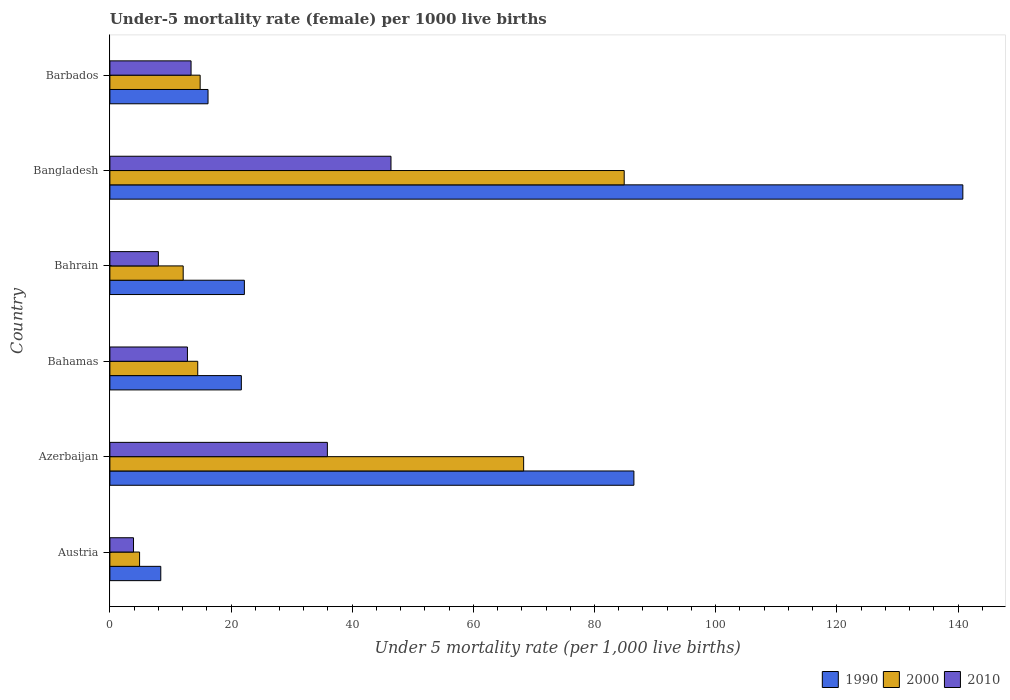How many different coloured bars are there?
Your answer should be very brief. 3. Are the number of bars per tick equal to the number of legend labels?
Keep it short and to the point. Yes. How many bars are there on the 1st tick from the top?
Ensure brevity in your answer.  3. In how many cases, is the number of bars for a given country not equal to the number of legend labels?
Give a very brief answer. 0. What is the under-five mortality rate in 1990 in Austria?
Make the answer very short. 8.4. Across all countries, what is the maximum under-five mortality rate in 2000?
Ensure brevity in your answer.  84.9. Across all countries, what is the minimum under-five mortality rate in 2010?
Your answer should be compact. 3.9. In which country was the under-five mortality rate in 1990 minimum?
Your response must be concise. Austria. What is the total under-five mortality rate in 1990 in the graph?
Give a very brief answer. 295.8. What is the difference between the under-five mortality rate in 2010 in Bangladesh and the under-five mortality rate in 1990 in Bahrain?
Your answer should be compact. 24.2. What is the average under-five mortality rate in 2010 per country?
Offer a very short reply. 20.07. What is the difference between the under-five mortality rate in 1990 and under-five mortality rate in 2000 in Barbados?
Keep it short and to the point. 1.3. In how many countries, is the under-five mortality rate in 1990 greater than 56 ?
Your response must be concise. 2. What is the ratio of the under-five mortality rate in 2010 in Azerbaijan to that in Bahamas?
Give a very brief answer. 2.8. What is the difference between the highest and the lowest under-five mortality rate in 2000?
Make the answer very short. 80. What does the 2nd bar from the top in Azerbaijan represents?
Your answer should be very brief. 2000. Is it the case that in every country, the sum of the under-five mortality rate in 1990 and under-five mortality rate in 2000 is greater than the under-five mortality rate in 2010?
Offer a terse response. Yes. How many bars are there?
Your answer should be compact. 18. How many countries are there in the graph?
Offer a very short reply. 6. What is the difference between two consecutive major ticks on the X-axis?
Provide a succinct answer. 20. Does the graph contain any zero values?
Your response must be concise. No. What is the title of the graph?
Ensure brevity in your answer.  Under-5 mortality rate (female) per 1000 live births. Does "2007" appear as one of the legend labels in the graph?
Give a very brief answer. No. What is the label or title of the X-axis?
Keep it short and to the point. Under 5 mortality rate (per 1,0 live births). What is the label or title of the Y-axis?
Your answer should be very brief. Country. What is the Under 5 mortality rate (per 1,000 live births) in 1990 in Austria?
Your answer should be compact. 8.4. What is the Under 5 mortality rate (per 1,000 live births) of 2000 in Austria?
Provide a short and direct response. 4.9. What is the Under 5 mortality rate (per 1,000 live births) in 1990 in Azerbaijan?
Ensure brevity in your answer.  86.5. What is the Under 5 mortality rate (per 1,000 live births) of 2000 in Azerbaijan?
Your answer should be very brief. 68.3. What is the Under 5 mortality rate (per 1,000 live births) in 2010 in Azerbaijan?
Keep it short and to the point. 35.9. What is the Under 5 mortality rate (per 1,000 live births) of 1990 in Bahamas?
Provide a short and direct response. 21.7. What is the Under 5 mortality rate (per 1,000 live births) of 2010 in Bahamas?
Your answer should be compact. 12.8. What is the Under 5 mortality rate (per 1,000 live births) in 1990 in Bahrain?
Offer a very short reply. 22.2. What is the Under 5 mortality rate (per 1,000 live births) of 2010 in Bahrain?
Your answer should be very brief. 8. What is the Under 5 mortality rate (per 1,000 live births) in 1990 in Bangladesh?
Your answer should be very brief. 140.8. What is the Under 5 mortality rate (per 1,000 live births) of 2000 in Bangladesh?
Make the answer very short. 84.9. What is the Under 5 mortality rate (per 1,000 live births) in 2010 in Bangladesh?
Provide a short and direct response. 46.4. What is the Under 5 mortality rate (per 1,000 live births) of 2010 in Barbados?
Your answer should be very brief. 13.4. Across all countries, what is the maximum Under 5 mortality rate (per 1,000 live births) in 1990?
Provide a succinct answer. 140.8. Across all countries, what is the maximum Under 5 mortality rate (per 1,000 live births) in 2000?
Offer a terse response. 84.9. Across all countries, what is the maximum Under 5 mortality rate (per 1,000 live births) in 2010?
Provide a succinct answer. 46.4. Across all countries, what is the minimum Under 5 mortality rate (per 1,000 live births) of 2000?
Your answer should be very brief. 4.9. What is the total Under 5 mortality rate (per 1,000 live births) of 1990 in the graph?
Provide a short and direct response. 295.8. What is the total Under 5 mortality rate (per 1,000 live births) in 2000 in the graph?
Ensure brevity in your answer.  199.6. What is the total Under 5 mortality rate (per 1,000 live births) of 2010 in the graph?
Give a very brief answer. 120.4. What is the difference between the Under 5 mortality rate (per 1,000 live births) of 1990 in Austria and that in Azerbaijan?
Your answer should be very brief. -78.1. What is the difference between the Under 5 mortality rate (per 1,000 live births) in 2000 in Austria and that in Azerbaijan?
Provide a succinct answer. -63.4. What is the difference between the Under 5 mortality rate (per 1,000 live births) of 2010 in Austria and that in Azerbaijan?
Give a very brief answer. -32. What is the difference between the Under 5 mortality rate (per 1,000 live births) in 1990 in Austria and that in Bahamas?
Your answer should be compact. -13.3. What is the difference between the Under 5 mortality rate (per 1,000 live births) in 2000 in Austria and that in Bahamas?
Make the answer very short. -9.6. What is the difference between the Under 5 mortality rate (per 1,000 live births) of 1990 in Austria and that in Bahrain?
Provide a short and direct response. -13.8. What is the difference between the Under 5 mortality rate (per 1,000 live births) in 2010 in Austria and that in Bahrain?
Provide a succinct answer. -4.1. What is the difference between the Under 5 mortality rate (per 1,000 live births) in 1990 in Austria and that in Bangladesh?
Ensure brevity in your answer.  -132.4. What is the difference between the Under 5 mortality rate (per 1,000 live births) of 2000 in Austria and that in Bangladesh?
Offer a terse response. -80. What is the difference between the Under 5 mortality rate (per 1,000 live births) in 2010 in Austria and that in Bangladesh?
Ensure brevity in your answer.  -42.5. What is the difference between the Under 5 mortality rate (per 1,000 live births) of 2000 in Austria and that in Barbados?
Keep it short and to the point. -10. What is the difference between the Under 5 mortality rate (per 1,000 live births) in 1990 in Azerbaijan and that in Bahamas?
Ensure brevity in your answer.  64.8. What is the difference between the Under 5 mortality rate (per 1,000 live births) of 2000 in Azerbaijan and that in Bahamas?
Your answer should be compact. 53.8. What is the difference between the Under 5 mortality rate (per 1,000 live births) of 2010 in Azerbaijan and that in Bahamas?
Provide a succinct answer. 23.1. What is the difference between the Under 5 mortality rate (per 1,000 live births) of 1990 in Azerbaijan and that in Bahrain?
Offer a terse response. 64.3. What is the difference between the Under 5 mortality rate (per 1,000 live births) of 2000 in Azerbaijan and that in Bahrain?
Give a very brief answer. 56.2. What is the difference between the Under 5 mortality rate (per 1,000 live births) of 2010 in Azerbaijan and that in Bahrain?
Make the answer very short. 27.9. What is the difference between the Under 5 mortality rate (per 1,000 live births) of 1990 in Azerbaijan and that in Bangladesh?
Your response must be concise. -54.3. What is the difference between the Under 5 mortality rate (per 1,000 live births) of 2000 in Azerbaijan and that in Bangladesh?
Offer a terse response. -16.6. What is the difference between the Under 5 mortality rate (per 1,000 live births) of 2010 in Azerbaijan and that in Bangladesh?
Provide a short and direct response. -10.5. What is the difference between the Under 5 mortality rate (per 1,000 live births) of 1990 in Azerbaijan and that in Barbados?
Keep it short and to the point. 70.3. What is the difference between the Under 5 mortality rate (per 1,000 live births) in 2000 in Azerbaijan and that in Barbados?
Provide a succinct answer. 53.4. What is the difference between the Under 5 mortality rate (per 1,000 live births) in 2010 in Azerbaijan and that in Barbados?
Your answer should be very brief. 22.5. What is the difference between the Under 5 mortality rate (per 1,000 live births) in 2000 in Bahamas and that in Bahrain?
Provide a succinct answer. 2.4. What is the difference between the Under 5 mortality rate (per 1,000 live births) of 1990 in Bahamas and that in Bangladesh?
Ensure brevity in your answer.  -119.1. What is the difference between the Under 5 mortality rate (per 1,000 live births) of 2000 in Bahamas and that in Bangladesh?
Provide a succinct answer. -70.4. What is the difference between the Under 5 mortality rate (per 1,000 live births) in 2010 in Bahamas and that in Bangladesh?
Ensure brevity in your answer.  -33.6. What is the difference between the Under 5 mortality rate (per 1,000 live births) of 1990 in Bahamas and that in Barbados?
Your answer should be very brief. 5.5. What is the difference between the Under 5 mortality rate (per 1,000 live births) of 2010 in Bahamas and that in Barbados?
Keep it short and to the point. -0.6. What is the difference between the Under 5 mortality rate (per 1,000 live births) of 1990 in Bahrain and that in Bangladesh?
Provide a succinct answer. -118.6. What is the difference between the Under 5 mortality rate (per 1,000 live births) in 2000 in Bahrain and that in Bangladesh?
Your response must be concise. -72.8. What is the difference between the Under 5 mortality rate (per 1,000 live births) in 2010 in Bahrain and that in Bangladesh?
Offer a terse response. -38.4. What is the difference between the Under 5 mortality rate (per 1,000 live births) of 2000 in Bahrain and that in Barbados?
Keep it short and to the point. -2.8. What is the difference between the Under 5 mortality rate (per 1,000 live births) of 2010 in Bahrain and that in Barbados?
Offer a terse response. -5.4. What is the difference between the Under 5 mortality rate (per 1,000 live births) in 1990 in Bangladesh and that in Barbados?
Your answer should be compact. 124.6. What is the difference between the Under 5 mortality rate (per 1,000 live births) in 2000 in Bangladesh and that in Barbados?
Provide a short and direct response. 70. What is the difference between the Under 5 mortality rate (per 1,000 live births) in 2010 in Bangladesh and that in Barbados?
Your answer should be compact. 33. What is the difference between the Under 5 mortality rate (per 1,000 live births) in 1990 in Austria and the Under 5 mortality rate (per 1,000 live births) in 2000 in Azerbaijan?
Offer a very short reply. -59.9. What is the difference between the Under 5 mortality rate (per 1,000 live births) in 1990 in Austria and the Under 5 mortality rate (per 1,000 live births) in 2010 in Azerbaijan?
Ensure brevity in your answer.  -27.5. What is the difference between the Under 5 mortality rate (per 1,000 live births) in 2000 in Austria and the Under 5 mortality rate (per 1,000 live births) in 2010 in Azerbaijan?
Give a very brief answer. -31. What is the difference between the Under 5 mortality rate (per 1,000 live births) in 1990 in Austria and the Under 5 mortality rate (per 1,000 live births) in 2010 in Bahrain?
Provide a succinct answer. 0.4. What is the difference between the Under 5 mortality rate (per 1,000 live births) of 2000 in Austria and the Under 5 mortality rate (per 1,000 live births) of 2010 in Bahrain?
Provide a succinct answer. -3.1. What is the difference between the Under 5 mortality rate (per 1,000 live births) in 1990 in Austria and the Under 5 mortality rate (per 1,000 live births) in 2000 in Bangladesh?
Your response must be concise. -76.5. What is the difference between the Under 5 mortality rate (per 1,000 live births) in 1990 in Austria and the Under 5 mortality rate (per 1,000 live births) in 2010 in Bangladesh?
Provide a short and direct response. -38. What is the difference between the Under 5 mortality rate (per 1,000 live births) in 2000 in Austria and the Under 5 mortality rate (per 1,000 live births) in 2010 in Bangladesh?
Give a very brief answer. -41.5. What is the difference between the Under 5 mortality rate (per 1,000 live births) in 2000 in Austria and the Under 5 mortality rate (per 1,000 live births) in 2010 in Barbados?
Provide a short and direct response. -8.5. What is the difference between the Under 5 mortality rate (per 1,000 live births) of 1990 in Azerbaijan and the Under 5 mortality rate (per 1,000 live births) of 2000 in Bahamas?
Offer a very short reply. 72. What is the difference between the Under 5 mortality rate (per 1,000 live births) of 1990 in Azerbaijan and the Under 5 mortality rate (per 1,000 live births) of 2010 in Bahamas?
Your answer should be compact. 73.7. What is the difference between the Under 5 mortality rate (per 1,000 live births) of 2000 in Azerbaijan and the Under 5 mortality rate (per 1,000 live births) of 2010 in Bahamas?
Your answer should be very brief. 55.5. What is the difference between the Under 5 mortality rate (per 1,000 live births) of 1990 in Azerbaijan and the Under 5 mortality rate (per 1,000 live births) of 2000 in Bahrain?
Offer a very short reply. 74.4. What is the difference between the Under 5 mortality rate (per 1,000 live births) of 1990 in Azerbaijan and the Under 5 mortality rate (per 1,000 live births) of 2010 in Bahrain?
Offer a terse response. 78.5. What is the difference between the Under 5 mortality rate (per 1,000 live births) of 2000 in Azerbaijan and the Under 5 mortality rate (per 1,000 live births) of 2010 in Bahrain?
Keep it short and to the point. 60.3. What is the difference between the Under 5 mortality rate (per 1,000 live births) in 1990 in Azerbaijan and the Under 5 mortality rate (per 1,000 live births) in 2000 in Bangladesh?
Provide a short and direct response. 1.6. What is the difference between the Under 5 mortality rate (per 1,000 live births) of 1990 in Azerbaijan and the Under 5 mortality rate (per 1,000 live births) of 2010 in Bangladesh?
Offer a terse response. 40.1. What is the difference between the Under 5 mortality rate (per 1,000 live births) in 2000 in Azerbaijan and the Under 5 mortality rate (per 1,000 live births) in 2010 in Bangladesh?
Provide a succinct answer. 21.9. What is the difference between the Under 5 mortality rate (per 1,000 live births) in 1990 in Azerbaijan and the Under 5 mortality rate (per 1,000 live births) in 2000 in Barbados?
Give a very brief answer. 71.6. What is the difference between the Under 5 mortality rate (per 1,000 live births) in 1990 in Azerbaijan and the Under 5 mortality rate (per 1,000 live births) in 2010 in Barbados?
Offer a very short reply. 73.1. What is the difference between the Under 5 mortality rate (per 1,000 live births) in 2000 in Azerbaijan and the Under 5 mortality rate (per 1,000 live births) in 2010 in Barbados?
Keep it short and to the point. 54.9. What is the difference between the Under 5 mortality rate (per 1,000 live births) of 1990 in Bahamas and the Under 5 mortality rate (per 1,000 live births) of 2000 in Bahrain?
Provide a succinct answer. 9.6. What is the difference between the Under 5 mortality rate (per 1,000 live births) of 1990 in Bahamas and the Under 5 mortality rate (per 1,000 live births) of 2010 in Bahrain?
Your response must be concise. 13.7. What is the difference between the Under 5 mortality rate (per 1,000 live births) in 2000 in Bahamas and the Under 5 mortality rate (per 1,000 live births) in 2010 in Bahrain?
Keep it short and to the point. 6.5. What is the difference between the Under 5 mortality rate (per 1,000 live births) in 1990 in Bahamas and the Under 5 mortality rate (per 1,000 live births) in 2000 in Bangladesh?
Your answer should be very brief. -63.2. What is the difference between the Under 5 mortality rate (per 1,000 live births) in 1990 in Bahamas and the Under 5 mortality rate (per 1,000 live births) in 2010 in Bangladesh?
Your answer should be compact. -24.7. What is the difference between the Under 5 mortality rate (per 1,000 live births) in 2000 in Bahamas and the Under 5 mortality rate (per 1,000 live births) in 2010 in Bangladesh?
Offer a terse response. -31.9. What is the difference between the Under 5 mortality rate (per 1,000 live births) of 1990 in Bahamas and the Under 5 mortality rate (per 1,000 live births) of 2010 in Barbados?
Your response must be concise. 8.3. What is the difference between the Under 5 mortality rate (per 1,000 live births) in 1990 in Bahrain and the Under 5 mortality rate (per 1,000 live births) in 2000 in Bangladesh?
Offer a very short reply. -62.7. What is the difference between the Under 5 mortality rate (per 1,000 live births) in 1990 in Bahrain and the Under 5 mortality rate (per 1,000 live births) in 2010 in Bangladesh?
Offer a terse response. -24.2. What is the difference between the Under 5 mortality rate (per 1,000 live births) in 2000 in Bahrain and the Under 5 mortality rate (per 1,000 live births) in 2010 in Bangladesh?
Your answer should be very brief. -34.3. What is the difference between the Under 5 mortality rate (per 1,000 live births) in 1990 in Bahrain and the Under 5 mortality rate (per 1,000 live births) in 2000 in Barbados?
Ensure brevity in your answer.  7.3. What is the difference between the Under 5 mortality rate (per 1,000 live births) in 1990 in Bahrain and the Under 5 mortality rate (per 1,000 live births) in 2010 in Barbados?
Give a very brief answer. 8.8. What is the difference between the Under 5 mortality rate (per 1,000 live births) in 2000 in Bahrain and the Under 5 mortality rate (per 1,000 live births) in 2010 in Barbados?
Your answer should be compact. -1.3. What is the difference between the Under 5 mortality rate (per 1,000 live births) in 1990 in Bangladesh and the Under 5 mortality rate (per 1,000 live births) in 2000 in Barbados?
Provide a succinct answer. 125.9. What is the difference between the Under 5 mortality rate (per 1,000 live births) in 1990 in Bangladesh and the Under 5 mortality rate (per 1,000 live births) in 2010 in Barbados?
Keep it short and to the point. 127.4. What is the difference between the Under 5 mortality rate (per 1,000 live births) in 2000 in Bangladesh and the Under 5 mortality rate (per 1,000 live births) in 2010 in Barbados?
Ensure brevity in your answer.  71.5. What is the average Under 5 mortality rate (per 1,000 live births) in 1990 per country?
Your answer should be very brief. 49.3. What is the average Under 5 mortality rate (per 1,000 live births) of 2000 per country?
Provide a short and direct response. 33.27. What is the average Under 5 mortality rate (per 1,000 live births) in 2010 per country?
Keep it short and to the point. 20.07. What is the difference between the Under 5 mortality rate (per 1,000 live births) of 1990 and Under 5 mortality rate (per 1,000 live births) of 2010 in Azerbaijan?
Your answer should be very brief. 50.6. What is the difference between the Under 5 mortality rate (per 1,000 live births) of 2000 and Under 5 mortality rate (per 1,000 live births) of 2010 in Azerbaijan?
Your answer should be very brief. 32.4. What is the difference between the Under 5 mortality rate (per 1,000 live births) in 1990 and Under 5 mortality rate (per 1,000 live births) in 2010 in Bahamas?
Offer a terse response. 8.9. What is the difference between the Under 5 mortality rate (per 1,000 live births) in 2000 and Under 5 mortality rate (per 1,000 live births) in 2010 in Bahamas?
Provide a short and direct response. 1.7. What is the difference between the Under 5 mortality rate (per 1,000 live births) in 1990 and Under 5 mortality rate (per 1,000 live births) in 2000 in Bahrain?
Offer a terse response. 10.1. What is the difference between the Under 5 mortality rate (per 1,000 live births) in 1990 and Under 5 mortality rate (per 1,000 live births) in 2010 in Bahrain?
Provide a succinct answer. 14.2. What is the difference between the Under 5 mortality rate (per 1,000 live births) of 2000 and Under 5 mortality rate (per 1,000 live births) of 2010 in Bahrain?
Keep it short and to the point. 4.1. What is the difference between the Under 5 mortality rate (per 1,000 live births) in 1990 and Under 5 mortality rate (per 1,000 live births) in 2000 in Bangladesh?
Provide a short and direct response. 55.9. What is the difference between the Under 5 mortality rate (per 1,000 live births) of 1990 and Under 5 mortality rate (per 1,000 live births) of 2010 in Bangladesh?
Your answer should be very brief. 94.4. What is the difference between the Under 5 mortality rate (per 1,000 live births) of 2000 and Under 5 mortality rate (per 1,000 live births) of 2010 in Bangladesh?
Your answer should be very brief. 38.5. What is the difference between the Under 5 mortality rate (per 1,000 live births) of 2000 and Under 5 mortality rate (per 1,000 live births) of 2010 in Barbados?
Ensure brevity in your answer.  1.5. What is the ratio of the Under 5 mortality rate (per 1,000 live births) of 1990 in Austria to that in Azerbaijan?
Offer a terse response. 0.1. What is the ratio of the Under 5 mortality rate (per 1,000 live births) of 2000 in Austria to that in Azerbaijan?
Offer a very short reply. 0.07. What is the ratio of the Under 5 mortality rate (per 1,000 live births) of 2010 in Austria to that in Azerbaijan?
Ensure brevity in your answer.  0.11. What is the ratio of the Under 5 mortality rate (per 1,000 live births) in 1990 in Austria to that in Bahamas?
Give a very brief answer. 0.39. What is the ratio of the Under 5 mortality rate (per 1,000 live births) of 2000 in Austria to that in Bahamas?
Offer a very short reply. 0.34. What is the ratio of the Under 5 mortality rate (per 1,000 live births) in 2010 in Austria to that in Bahamas?
Provide a short and direct response. 0.3. What is the ratio of the Under 5 mortality rate (per 1,000 live births) in 1990 in Austria to that in Bahrain?
Make the answer very short. 0.38. What is the ratio of the Under 5 mortality rate (per 1,000 live births) in 2000 in Austria to that in Bahrain?
Offer a very short reply. 0.41. What is the ratio of the Under 5 mortality rate (per 1,000 live births) in 2010 in Austria to that in Bahrain?
Offer a terse response. 0.49. What is the ratio of the Under 5 mortality rate (per 1,000 live births) of 1990 in Austria to that in Bangladesh?
Make the answer very short. 0.06. What is the ratio of the Under 5 mortality rate (per 1,000 live births) in 2000 in Austria to that in Bangladesh?
Offer a very short reply. 0.06. What is the ratio of the Under 5 mortality rate (per 1,000 live births) of 2010 in Austria to that in Bangladesh?
Provide a succinct answer. 0.08. What is the ratio of the Under 5 mortality rate (per 1,000 live births) of 1990 in Austria to that in Barbados?
Provide a short and direct response. 0.52. What is the ratio of the Under 5 mortality rate (per 1,000 live births) in 2000 in Austria to that in Barbados?
Offer a terse response. 0.33. What is the ratio of the Under 5 mortality rate (per 1,000 live births) in 2010 in Austria to that in Barbados?
Offer a terse response. 0.29. What is the ratio of the Under 5 mortality rate (per 1,000 live births) in 1990 in Azerbaijan to that in Bahamas?
Provide a short and direct response. 3.99. What is the ratio of the Under 5 mortality rate (per 1,000 live births) in 2000 in Azerbaijan to that in Bahamas?
Keep it short and to the point. 4.71. What is the ratio of the Under 5 mortality rate (per 1,000 live births) in 2010 in Azerbaijan to that in Bahamas?
Your answer should be compact. 2.8. What is the ratio of the Under 5 mortality rate (per 1,000 live births) in 1990 in Azerbaijan to that in Bahrain?
Your answer should be compact. 3.9. What is the ratio of the Under 5 mortality rate (per 1,000 live births) in 2000 in Azerbaijan to that in Bahrain?
Your answer should be very brief. 5.64. What is the ratio of the Under 5 mortality rate (per 1,000 live births) in 2010 in Azerbaijan to that in Bahrain?
Ensure brevity in your answer.  4.49. What is the ratio of the Under 5 mortality rate (per 1,000 live births) of 1990 in Azerbaijan to that in Bangladesh?
Offer a very short reply. 0.61. What is the ratio of the Under 5 mortality rate (per 1,000 live births) of 2000 in Azerbaijan to that in Bangladesh?
Offer a terse response. 0.8. What is the ratio of the Under 5 mortality rate (per 1,000 live births) of 2010 in Azerbaijan to that in Bangladesh?
Your response must be concise. 0.77. What is the ratio of the Under 5 mortality rate (per 1,000 live births) of 1990 in Azerbaijan to that in Barbados?
Offer a terse response. 5.34. What is the ratio of the Under 5 mortality rate (per 1,000 live births) of 2000 in Azerbaijan to that in Barbados?
Your response must be concise. 4.58. What is the ratio of the Under 5 mortality rate (per 1,000 live births) in 2010 in Azerbaijan to that in Barbados?
Your answer should be very brief. 2.68. What is the ratio of the Under 5 mortality rate (per 1,000 live births) in 1990 in Bahamas to that in Bahrain?
Give a very brief answer. 0.98. What is the ratio of the Under 5 mortality rate (per 1,000 live births) in 2000 in Bahamas to that in Bahrain?
Make the answer very short. 1.2. What is the ratio of the Under 5 mortality rate (per 1,000 live births) of 1990 in Bahamas to that in Bangladesh?
Provide a short and direct response. 0.15. What is the ratio of the Under 5 mortality rate (per 1,000 live births) in 2000 in Bahamas to that in Bangladesh?
Your answer should be very brief. 0.17. What is the ratio of the Under 5 mortality rate (per 1,000 live births) in 2010 in Bahamas to that in Bangladesh?
Keep it short and to the point. 0.28. What is the ratio of the Under 5 mortality rate (per 1,000 live births) in 1990 in Bahamas to that in Barbados?
Ensure brevity in your answer.  1.34. What is the ratio of the Under 5 mortality rate (per 1,000 live births) in 2000 in Bahamas to that in Barbados?
Give a very brief answer. 0.97. What is the ratio of the Under 5 mortality rate (per 1,000 live births) of 2010 in Bahamas to that in Barbados?
Keep it short and to the point. 0.96. What is the ratio of the Under 5 mortality rate (per 1,000 live births) in 1990 in Bahrain to that in Bangladesh?
Give a very brief answer. 0.16. What is the ratio of the Under 5 mortality rate (per 1,000 live births) in 2000 in Bahrain to that in Bangladesh?
Provide a short and direct response. 0.14. What is the ratio of the Under 5 mortality rate (per 1,000 live births) of 2010 in Bahrain to that in Bangladesh?
Offer a terse response. 0.17. What is the ratio of the Under 5 mortality rate (per 1,000 live births) in 1990 in Bahrain to that in Barbados?
Make the answer very short. 1.37. What is the ratio of the Under 5 mortality rate (per 1,000 live births) in 2000 in Bahrain to that in Barbados?
Your answer should be compact. 0.81. What is the ratio of the Under 5 mortality rate (per 1,000 live births) in 2010 in Bahrain to that in Barbados?
Provide a succinct answer. 0.6. What is the ratio of the Under 5 mortality rate (per 1,000 live births) of 1990 in Bangladesh to that in Barbados?
Provide a succinct answer. 8.69. What is the ratio of the Under 5 mortality rate (per 1,000 live births) in 2000 in Bangladesh to that in Barbados?
Give a very brief answer. 5.7. What is the ratio of the Under 5 mortality rate (per 1,000 live births) in 2010 in Bangladesh to that in Barbados?
Ensure brevity in your answer.  3.46. What is the difference between the highest and the second highest Under 5 mortality rate (per 1,000 live births) in 1990?
Make the answer very short. 54.3. What is the difference between the highest and the second highest Under 5 mortality rate (per 1,000 live births) in 2000?
Keep it short and to the point. 16.6. What is the difference between the highest and the second highest Under 5 mortality rate (per 1,000 live births) in 2010?
Keep it short and to the point. 10.5. What is the difference between the highest and the lowest Under 5 mortality rate (per 1,000 live births) in 1990?
Offer a terse response. 132.4. What is the difference between the highest and the lowest Under 5 mortality rate (per 1,000 live births) in 2010?
Provide a succinct answer. 42.5. 